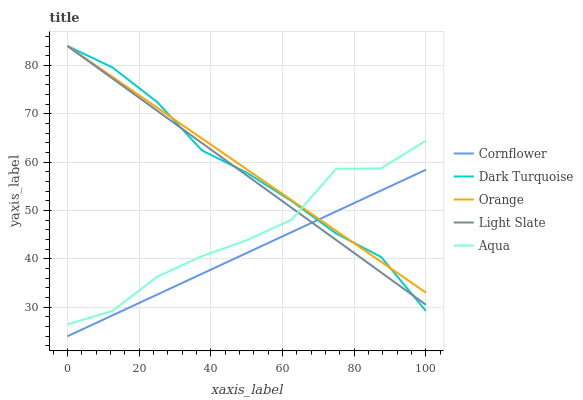Does Cornflower have the minimum area under the curve?
Answer yes or no. Yes. Does Orange have the maximum area under the curve?
Answer yes or no. Yes. Does Aqua have the minimum area under the curve?
Answer yes or no. No. Does Aqua have the maximum area under the curve?
Answer yes or no. No. Is Cornflower the smoothest?
Answer yes or no. Yes. Is Aqua the roughest?
Answer yes or no. Yes. Is Aqua the smoothest?
Answer yes or no. No. Is Cornflower the roughest?
Answer yes or no. No. Does Cornflower have the lowest value?
Answer yes or no. Yes. Does Aqua have the lowest value?
Answer yes or no. No. Does Dark Turquoise have the highest value?
Answer yes or no. Yes. Does Aqua have the highest value?
Answer yes or no. No. Is Cornflower less than Aqua?
Answer yes or no. Yes. Is Aqua greater than Cornflower?
Answer yes or no. Yes. Does Orange intersect Light Slate?
Answer yes or no. Yes. Is Orange less than Light Slate?
Answer yes or no. No. Is Orange greater than Light Slate?
Answer yes or no. No. Does Cornflower intersect Aqua?
Answer yes or no. No. 